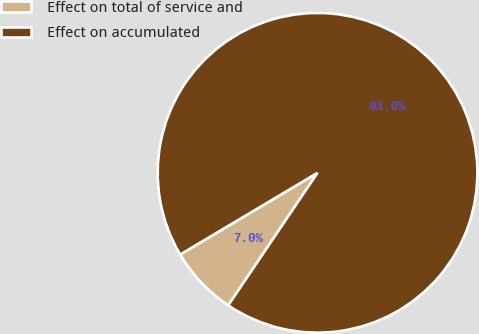<chart> <loc_0><loc_0><loc_500><loc_500><pie_chart><fcel>Effect on total of service and<fcel>Effect on accumulated<nl><fcel>7.02%<fcel>92.98%<nl></chart> 